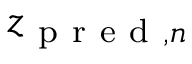<formula> <loc_0><loc_0><loc_500><loc_500>z _ { p r e d , n }</formula> 